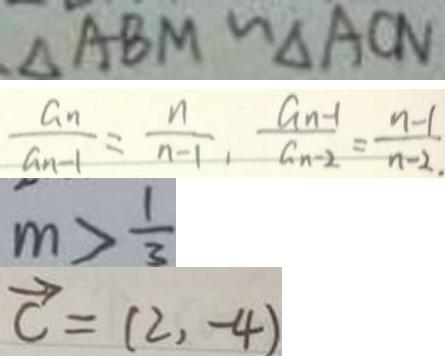Convert formula to latex. <formula><loc_0><loc_0><loc_500><loc_500>\Delta A B M \sim \Delta A C N 
 \frac { a _ { n } } { a _ { n - 1 } } = \frac { n } { n - 1 } , \frac { a _ { n } - 1 } { a _ { n - 2 } } = \frac { n - 1 } { n - 2 . } 
 m > \frac { 1 } { 3 } 
 \overrightarrow { c } = ( 2 , - 4 )</formula> 